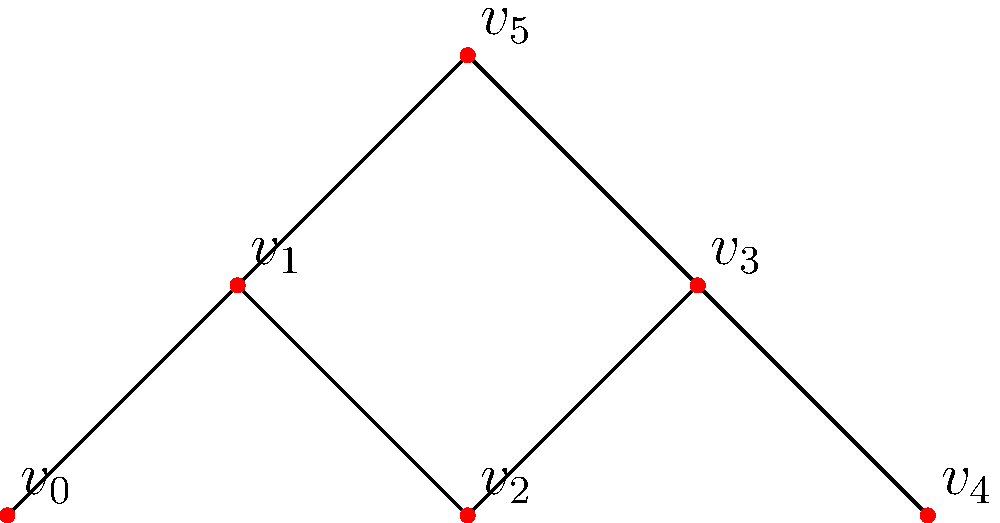Consider the graph representing bird migration paths between different habitats. Is this graph 2-connected? If not, identify the cut vertex (or vertices) that, when removed, would disconnect the graph. To determine if the graph is 2-connected and identify any cut vertices, we need to follow these steps:

1. Recall that a graph is 2-connected if it remains connected after removing any single vertex.

2. Analyze each vertex:
   a) $v_0$: Removing it doesn't disconnect the graph.
   b) $v_1$: Removing it disconnects $v_0$ from the rest of the graph.
   c) $v_2$: Removing it doesn't disconnect the graph.
   d) $v_3$: Removing it disconnects $v_4$ from the rest of the graph.
   e) $v_4$: Removing it doesn't disconnect the graph.
   f) $v_5$: Removing it doesn't disconnect the graph.

3. We found that removing either $v_1$ or $v_3$ disconnects the graph.

4. The existence of cut vertices ($v_1$ and $v_3$) means the graph is not 2-connected.

5. In the context of bird migration paths, $v_1$ and $v_3$ represent critical habitats or stopover points that, if lost, would significantly disrupt the migration network.
Answer: Not 2-connected; cut vertices are $v_1$ and $v_3$ 